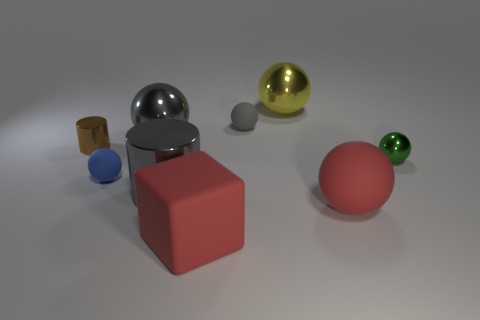There is a shiny sphere to the left of the large gray metal cylinder; does it have the same size as the rubber ball in front of the big cylinder?
Your response must be concise. Yes. Are there any big brown objects that have the same material as the small blue ball?
Your response must be concise. No. How many objects are metal balls that are to the left of the large red rubber sphere or big gray shiny spheres?
Offer a terse response. 2. Does the red object that is to the left of the red rubber ball have the same material as the small blue sphere?
Your answer should be compact. Yes. Does the green thing have the same shape as the big yellow metallic object?
Your answer should be compact. Yes. How many big red things are in front of the rubber sphere to the right of the gray matte ball?
Make the answer very short. 1. What is the material of the big red object that is the same shape as the small green shiny thing?
Offer a terse response. Rubber. Is the color of the big matte sphere behind the matte cube the same as the big matte cube?
Your answer should be compact. Yes. Is the green ball made of the same material as the cylinder behind the blue ball?
Ensure brevity in your answer.  Yes. There is a tiny metallic object that is to the right of the matte cube; what is its shape?
Provide a succinct answer. Sphere. 